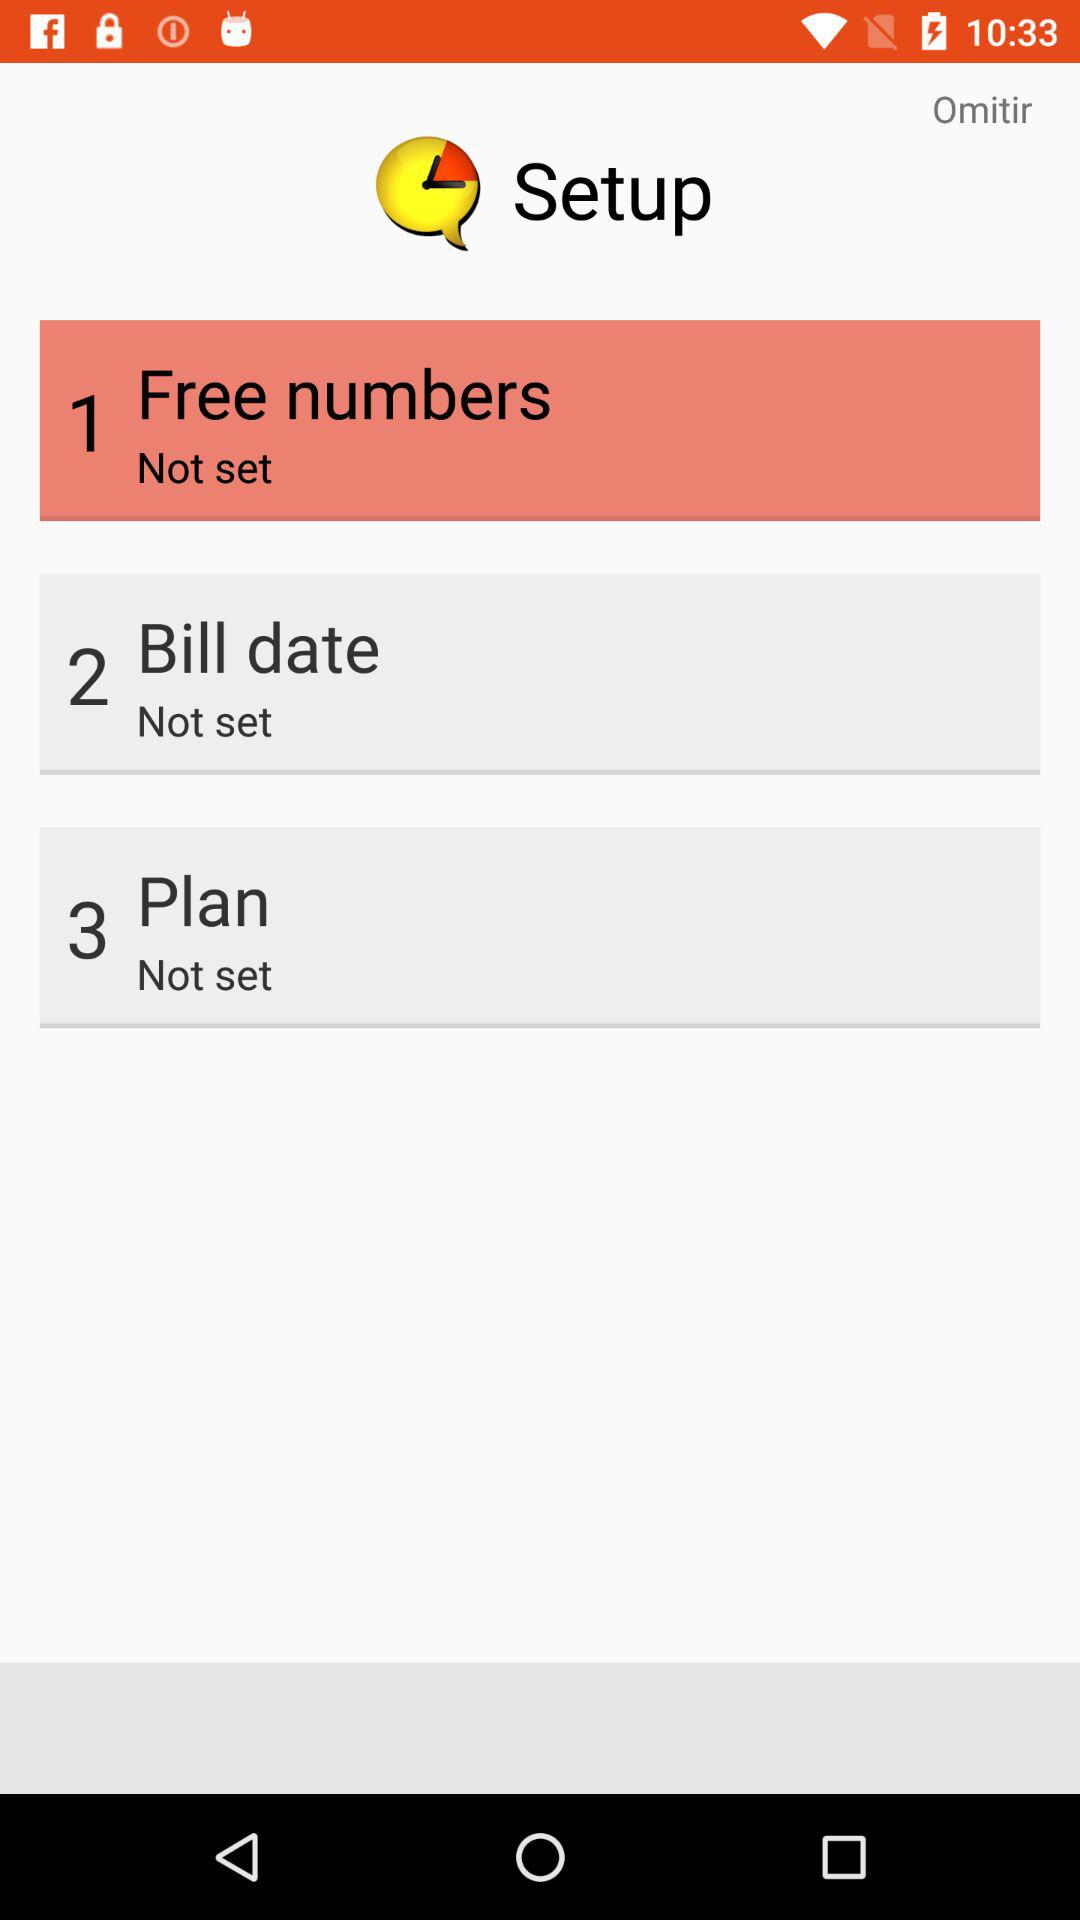What is the setting for the "Bill date"? The setting for the "Bill date" is "Not set". 